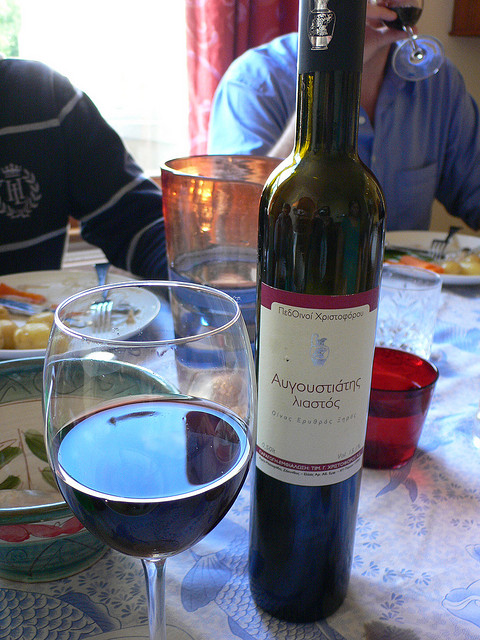<image>What is the alcohol content of this wine? It is impossible to determine the alcohol content of the wine without further information. What is the alcohol content of this wine? I don't know what is the alcohol content of this wine. It can be any percentage between 0.50% and 54%. 